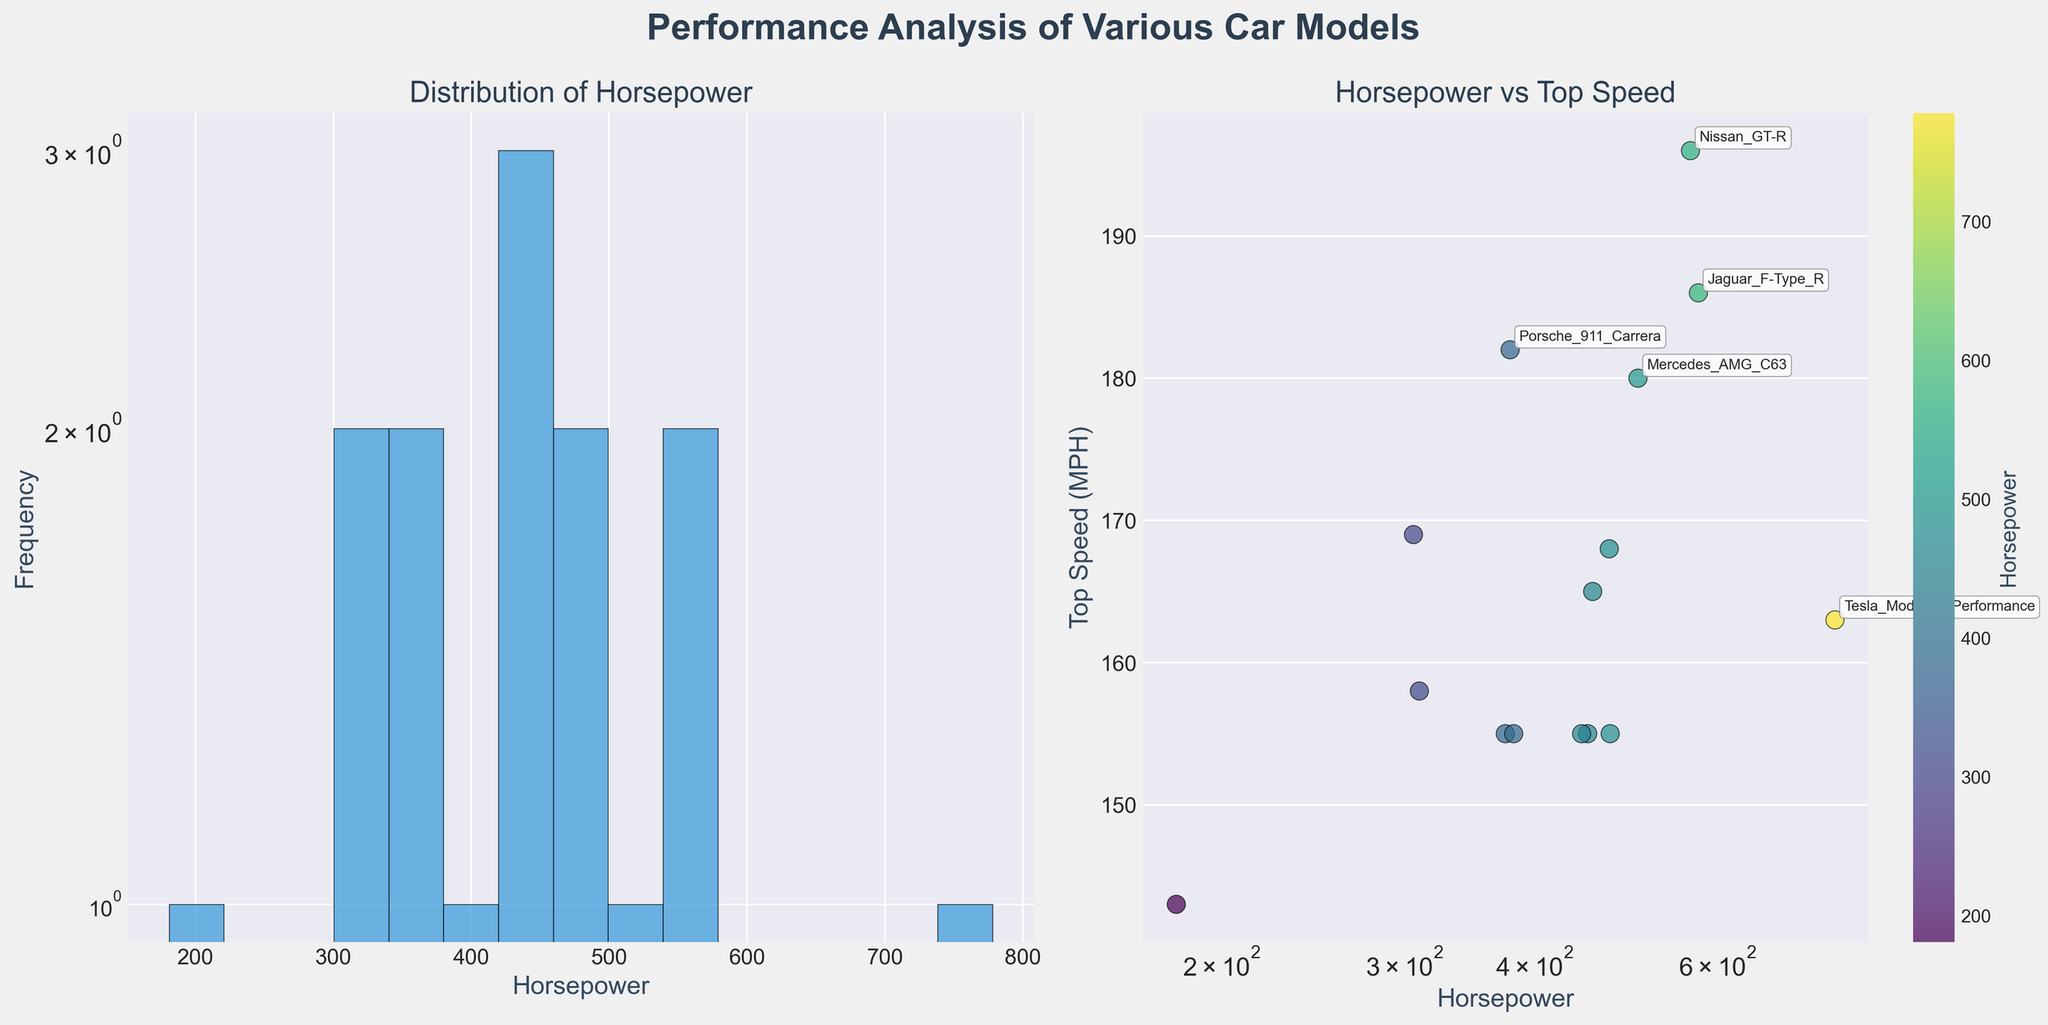What is the title of the left subplot? The title of the left subplot is directly mentioned above the histogram.
Answer: Distribution of Horsepower How many car models are shown in the horsepower vs. top speed plot? To count the number of car models, look for the number of data points (scatter points) visible in the right subplot. Each point represents a car model. There are 15 data points in the scatter plot, indicating 15 car models.
Answer: 15 What is the color used for the histogram bars in the horsepower distribution? The color used for the histogram bars is observed from the left subplot, which shows blue bars.
Answer: Blue Which car model has both the highest horsepower and the highest top speed? Locate the points and annotations; the Nissan GT-R has the highest horsepower (565) associated with its highest top speed (196 MPH).
Answer: Nissan GT-R What is the range of horsepower values observed in the histogram? The range of horsepower values can be observed by looking at the x-axis of the histogram, which spans from the least to the most horsepower value. The range is from 181 to 778.
Answer: 181 to 778 How does the top speed of the Mercedes AMG C63 compare to the Lexus RC F? Observe the positions of the data points corresponding to Mercedes AMG C63 and Lexus RC F in the scatter plot. Mercedes AMG C63 has a top speed of 180 MPH, while Lexus RC F has a top speed of 168 MPH, so the Mercedes AMG C63 is faster.
Answer: Mercedes AMG C63 is faster What is the common top speed among several car models, and name these models? From the scatter plot, observe that there are multiple points at the top speed of 155 MPH. The models include Ford Mustang GT, Dodge Challenger RT, BMW M4, Audi RS5, and Toyota Supra.
Answer: 155 MPH, Ford Mustang GT, Dodge Challenger RT, BMW M4, Audi RS5, Toyota Supra What is the color gradient used in the scatter plot? The scatter plot uses a color gradient from light to dark green (viridis colormap) to denote increasing horsepower values.
Answer: Light to dark green How many car models exceed a top speed of 180 MPH? From the scatter plot, count the number of points with top speed values above 180 MPH, which include Mercedes AMG C63, Nissan GT-R, and Porsche 911 Carrera.
Answer: 3 models What is the frequency of cars with horsepower between 300 and 400 in the histogram? Count the number of bars that fall within the 300-400 horsepower range in the histogram, and observe the corresponding y-axis values. Two bars fall within this range, with frequencies around 2 each, totaling 4.
Answer: 4 